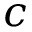<formula> <loc_0><loc_0><loc_500><loc_500>c</formula> 